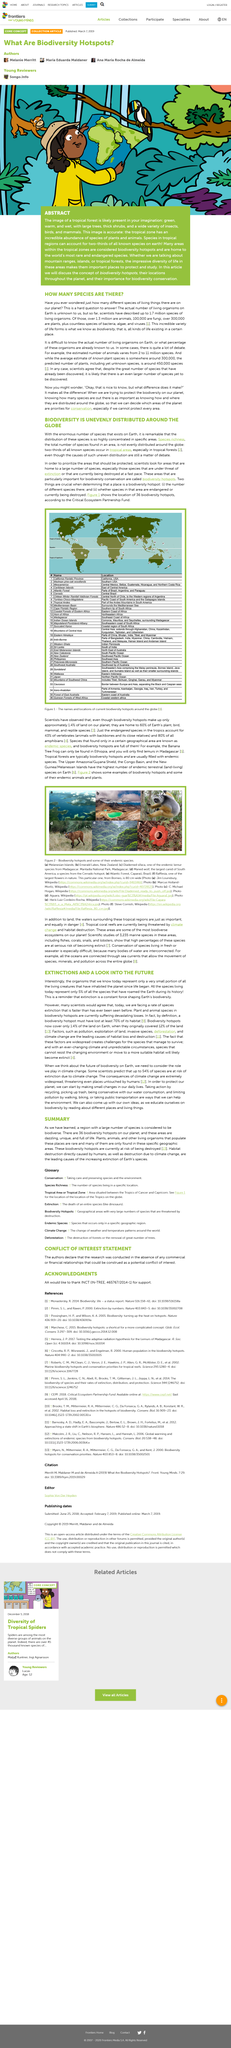Identify some key points in this picture. The image in Figure 2 was taken in New Zealand. The maned wolf is the animal depicted in image (d) of Figure 2. Figure 1 depicts 36 biodiversity hotspots, as identified by the Critical Ecosystem Partnership Fund. Climate change poses a significant threat to the survival of many species, with as much as 54% of all species predicted to be at risk of extinction by scientists, based on current predictions. Figure 1 displays the current biodiversity hotspots around the world, highlighting the names and locations of these areas of high biological diversity. 